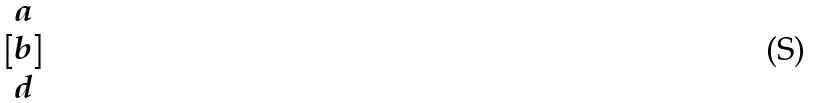<formula> <loc_0><loc_0><loc_500><loc_500>[ \begin{matrix} a \\ b \\ d \end{matrix} ]</formula> 